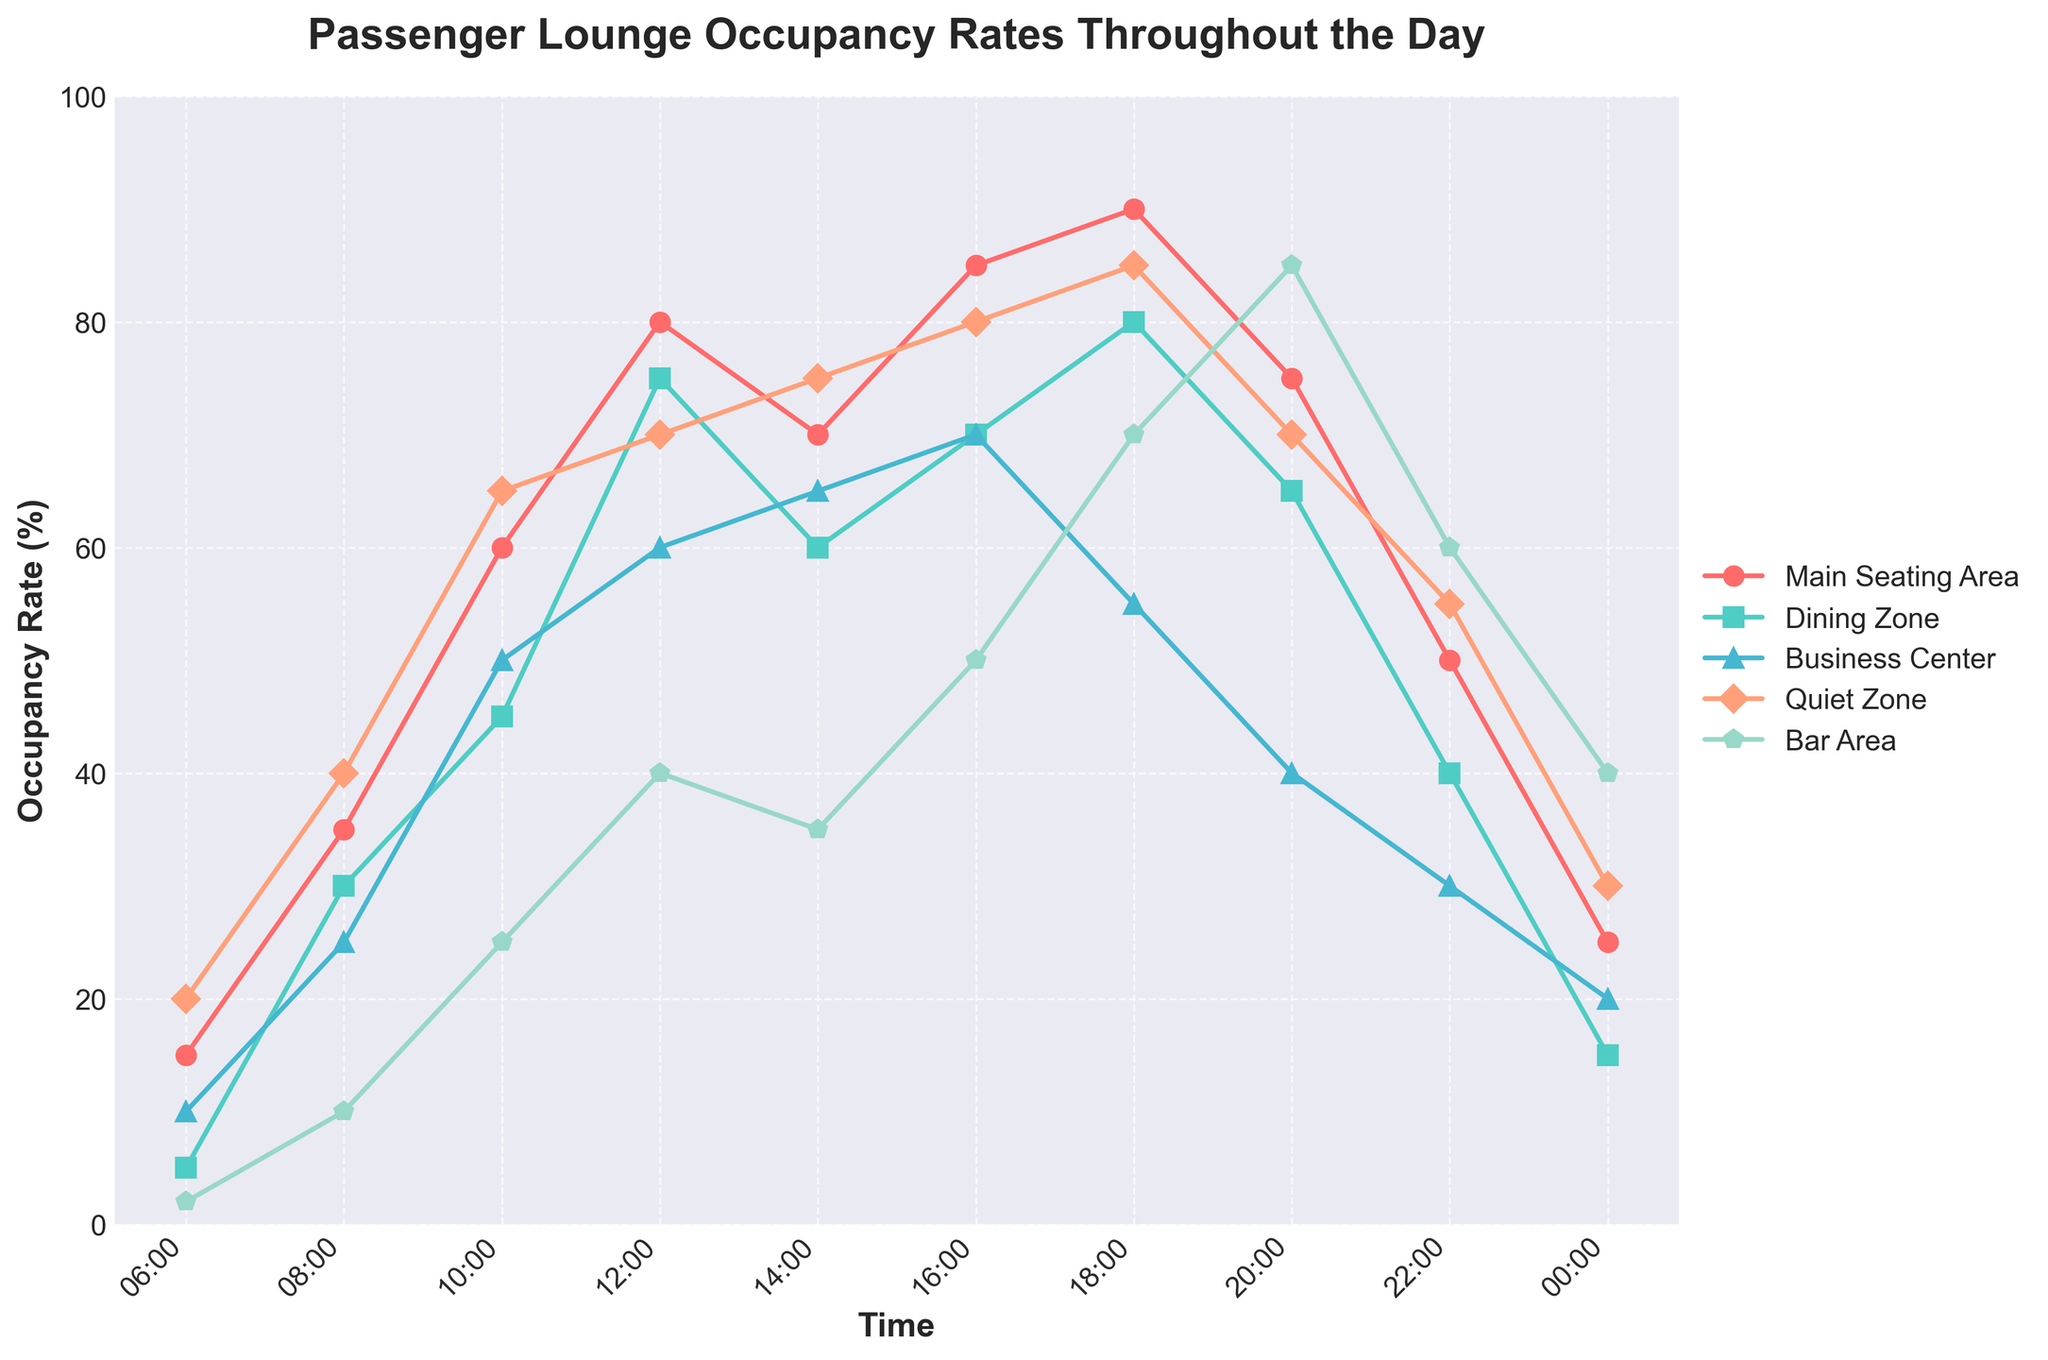What time has the highest overall occupancy rate across all areas combined? To find the highest overall occupancy rate, add the occupancy rates across all areas for each time slot and compare. For 16:00, the rates are 85%, 70%, 70%, 80%, and 50%, summing to 355%, which is higher than other times.
Answer: 16:00 Which area has the highest occupancy rate at 12:00? At 12:00, the occupancy rates are Main Seating Area 80%, Dining Zone 75%, Business Center 60%, Quiet Zone 70%, Bar Area 40%. The highest rate is in the Main Seating Area with 80%.
Answer: Main Seating Area How does the occupancy rate in the Quiet Zone at 14:00 compare to the rate in the Bar Area at the same time? At 14:00, the Quiet Zone has an occupancy rate of 75%, and the Bar area has 35%. So, the Quiet Zone has a 40% higher rate than the Bar area.
Answer: Quiet Zone is 40% higher What is the trend in the Dining Zone occupancy rate from 06:00 to 18:00? The rates are 5%, 30%, 45%, 75%, 60%, 70%, 80% respectively. The trend is a general increase with some fluctuations: sharp rise from 06:00 to 12:00, slight dip at 14:00, and continuing rise to 18:00.
Answer: Generally increasing At what times is the Business Center occupancy rate equal to or greater than 50%? The Business Center has occupancy rates at or above 50% at 10:00 (50%), 12:00 (60%), 14:00 (65%), 16:00 (70%).
Answer: 10:00, 12:00, 14:00, 16:00 What is the difference between the highest and lowest occupancy rates in the Main Seating Area? The Main Seating Area ranges from 15% at 06:00 to 90% at 18:00. The difference is 90% - 15% = 75%.
Answer: 75% During which two-hour period is there the biggest drop in Dining Zone occupancy? To find the biggest drop, compare successive two-hour intervals. The biggest drop is from 18:00 (80%) to 20:00 (65%), with a change of 15%.
Answer: 18:00 to 20:00 What is the combined occupancy percentage of all areas at 20:00? For 20:00, sum the occupancy rates of all areas, which are 75%, 65%, 40%, 70%, and 85%. The total is 75 + 65 + 40 + 70 + 85 = 335%.
Answer: 335% 